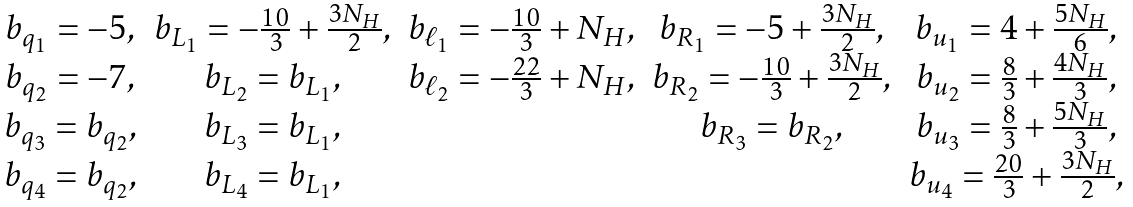<formula> <loc_0><loc_0><loc_500><loc_500>\begin{array} { c c c c c } b _ { q _ { 1 } } = - 5 , & b _ { L _ { 1 } } = - \frac { 1 0 } { 3 } + \frac { 3 N _ { H } } { 2 } , & b _ { \ell _ { 1 } } = - \frac { 1 0 } { 3 } + N _ { H } , & b _ { R _ { 1 } } = - 5 + \frac { 3 N _ { H } } { 2 } , & b _ { u _ { 1 } } = 4 + \frac { 5 N _ { H } } { 6 } , \\ b _ { q _ { 2 } } = - 7 , & b _ { L _ { 2 } } = b _ { L _ { 1 } } , & b _ { \ell _ { 2 } } = - \frac { 2 2 } { 3 } + N _ { H } , & b _ { R _ { 2 } } = - \frac { 1 0 } { 3 } + \frac { 3 N _ { H } } { 2 } , & b _ { u _ { 2 } } = \frac { 8 } { 3 } + \frac { 4 N _ { H } } { 3 } , \\ b _ { q _ { 3 } } = b _ { q _ { 2 } } , & b _ { L _ { 3 } } = b _ { L _ { 1 } } , & & b _ { R _ { 3 } } = b _ { R _ { 2 } } , & b _ { u _ { 3 } } = \frac { 8 } { 3 } + \frac { 5 N _ { H } } { 3 } , \\ b _ { q _ { 4 } } = b _ { q _ { 2 } } , & b _ { L _ { 4 } } = b _ { L _ { 1 } } , & & & b _ { u _ { 4 } } = \frac { 2 0 } { 3 } + \frac { 3 N _ { H } } { 2 } , \end{array}</formula> 